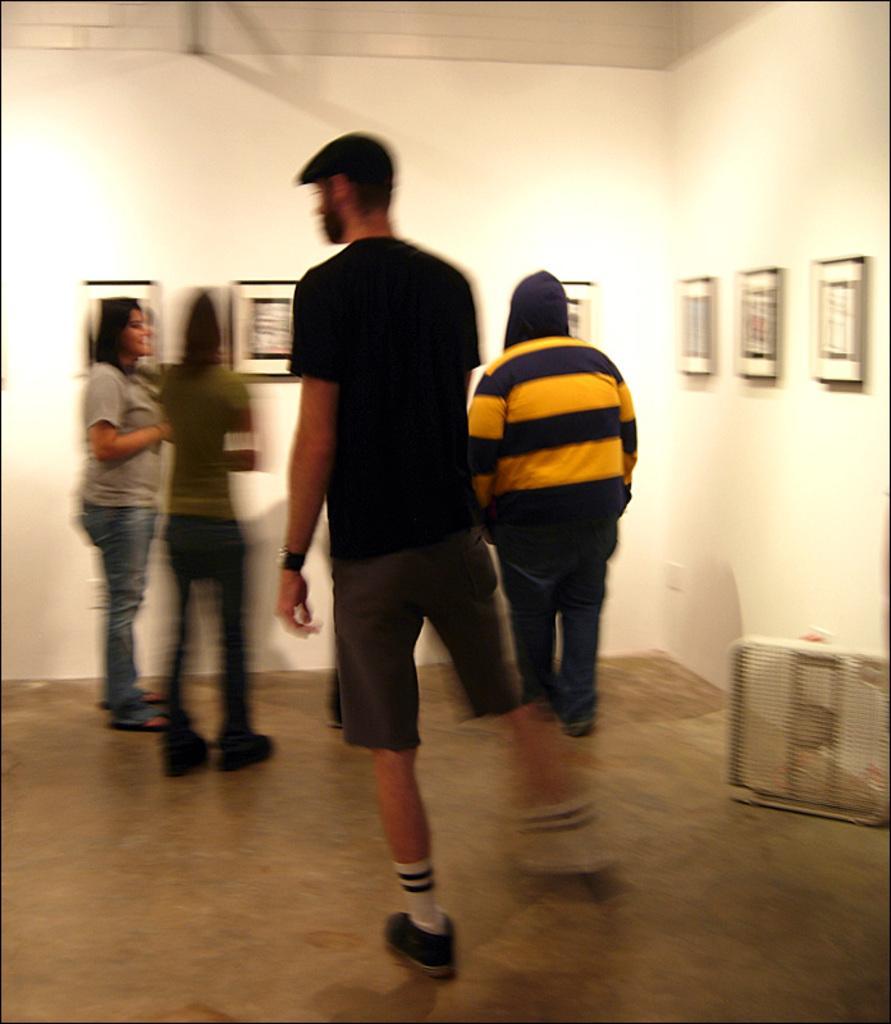Please provide a concise description of this image. In this image I can see inside view of a room and in the centre I can see few people are standing. I can also see number of frames on the walls and on the right side of this image I can see an object. 